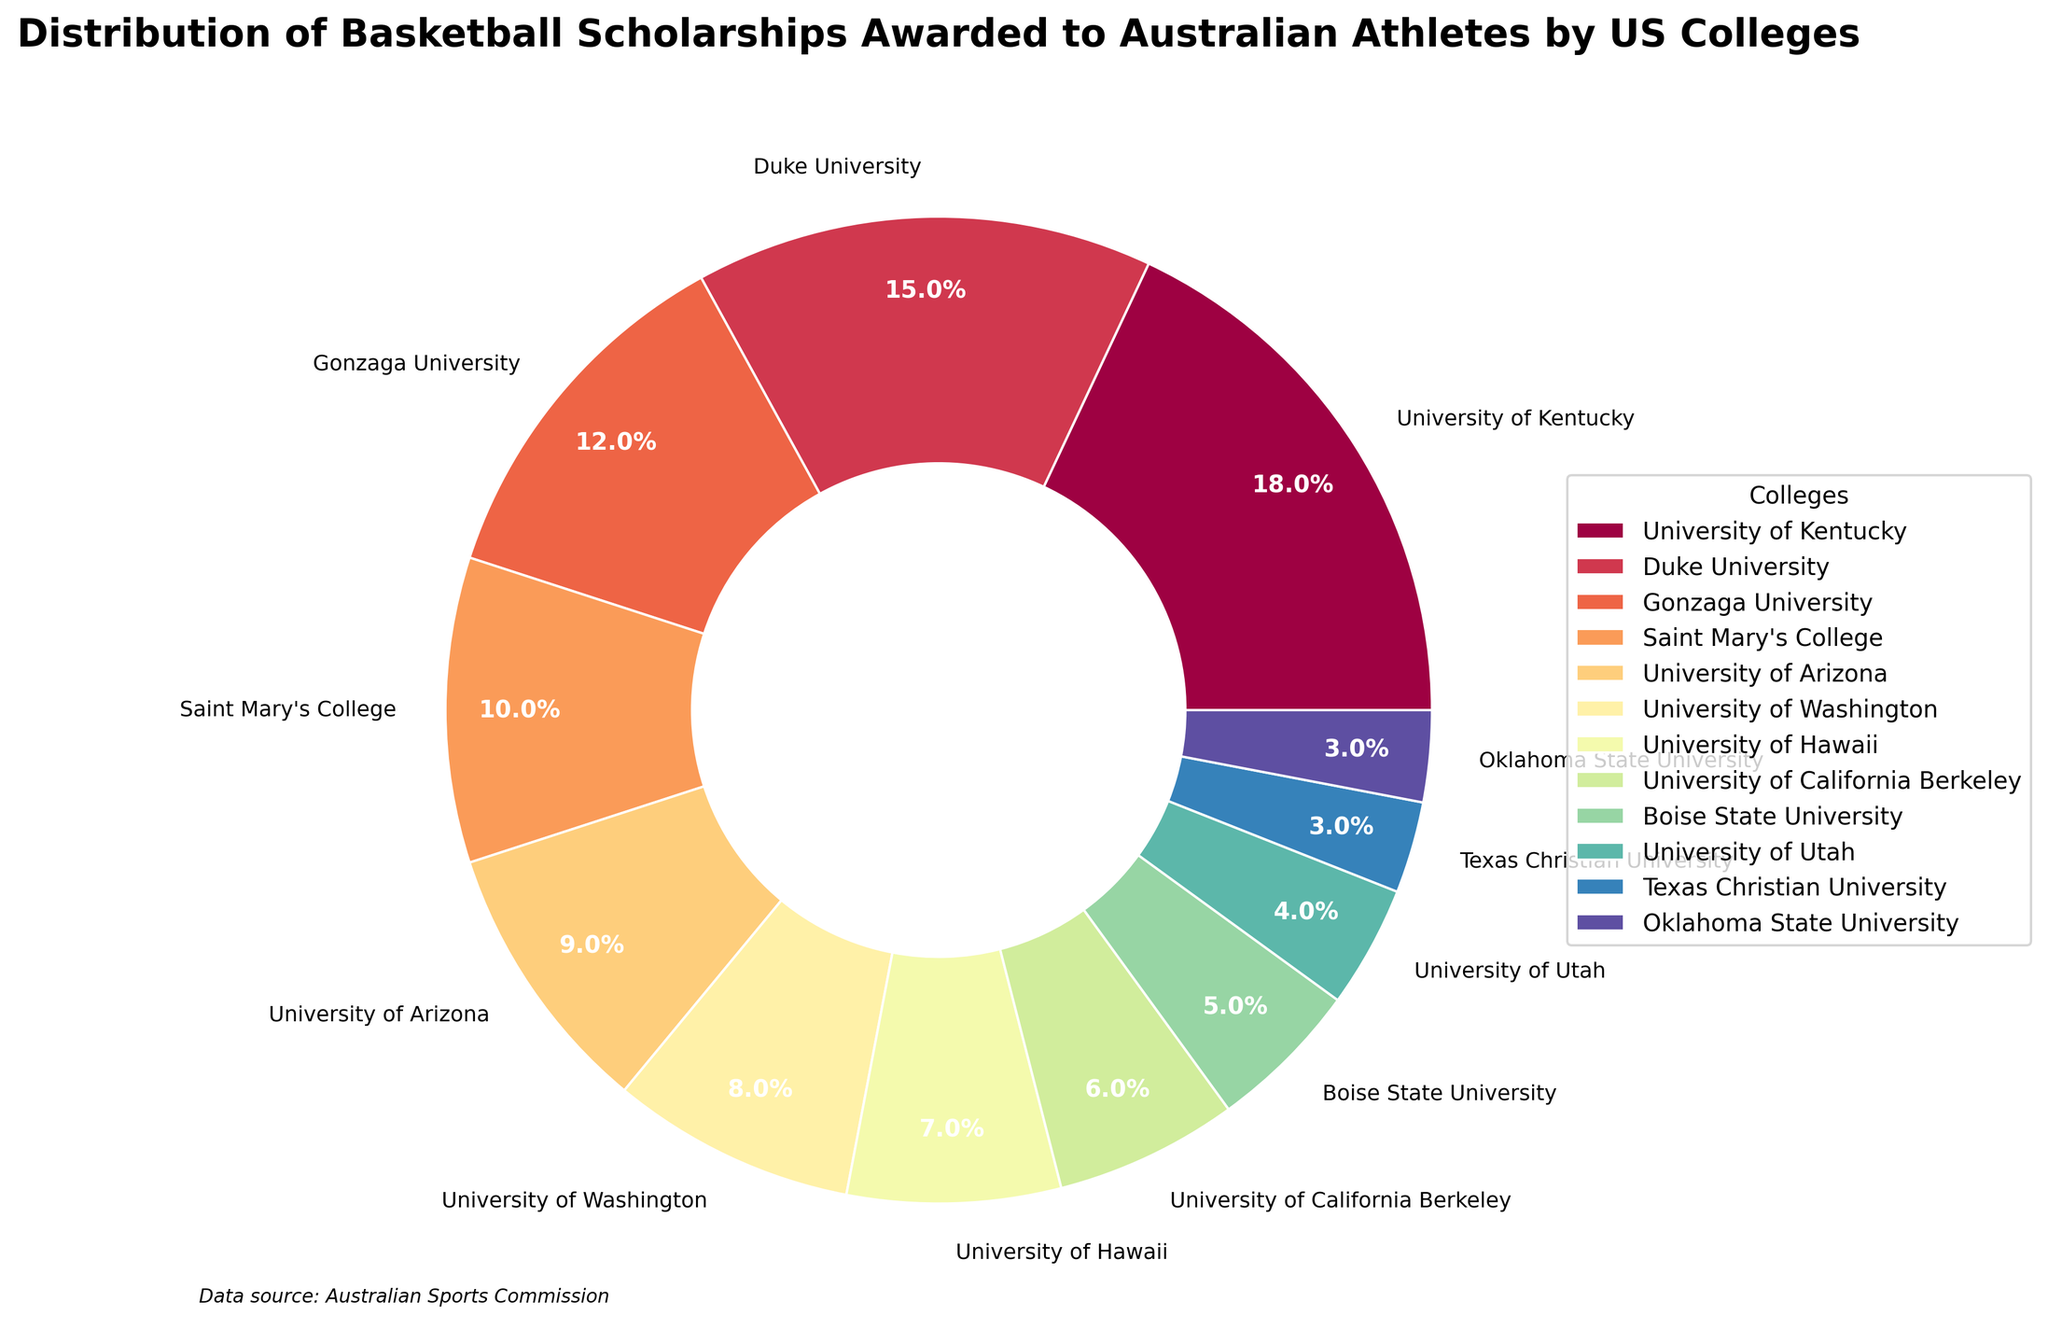which college awarded the most scholarships to Australian athletes? University of Kentucky stands out as the college with the largest segment in the pie chart, indicating it has awarded the most scholarships.
Answer: University of Kentucky What percentage of scholarships were awarded by Duke University? Duke University's slice of the pie is labeled with the percentage 15%.
Answer: 15% Is it true that Gonzaga University awarded more scholarships than Saint Mary's College? Gonzaga University has a larger segment in the pie chart than Saint Mary's College, indicating it awarded more scholarships.
Answer: True How many more scholarships did the University of Kentucky award compared to the University of Utah? The University of Kentucky awarded 18 scholarships, and the University of Utah awarded 4. The difference is 18 - 4 = 14 scholarships.
Answer: 14 scholarships What is the total number of scholarships awarded by the three colleges that offered the least scholarships? Texas Christian University, Oklahoma State University, and the University of Utah awarded 3, 3, and 4 scholarships respectively. So, 3 + 3 + 4 = 10 scholarships.
Answer: 10 scholarships Whose slice in the pie chart is bigger, University of Washington or University of California Berkeley? The University of Washington has a larger segment than the University of California Berkeley, indicating it awarded more scholarships.
Answer: University of Washington What fraction of the total scholarships was awarded by Saint Mary's College? Saint Mary's College awarded 10 scholarships. The total scholarships awarded is the sum of all values, which equals 100. So, the fraction is 10/100, which simplifies to 1/10 or 10%.
Answer: 10% Which college awarded the smallest number of scholarships and what is its share in percent? Both Texas Christian University and Oklahoma State University awarded the smallest number of scholarships, with each contributing 3, which corresponds to a 3% share each.
Answer: Texas Christian University and Oklahoma State University, 3% If you combined the scholarships awarded by the University of Hawaii and Boise State University, what percentage of the total scholarships would they represent? The University of Hawaii awarded 7 scholarships, and Boise State University awarded 5. Combined, they awarded 7 + 5 = 12 scholarships. This is 12/100 of the total, which is 12%.
Answer: 12% 